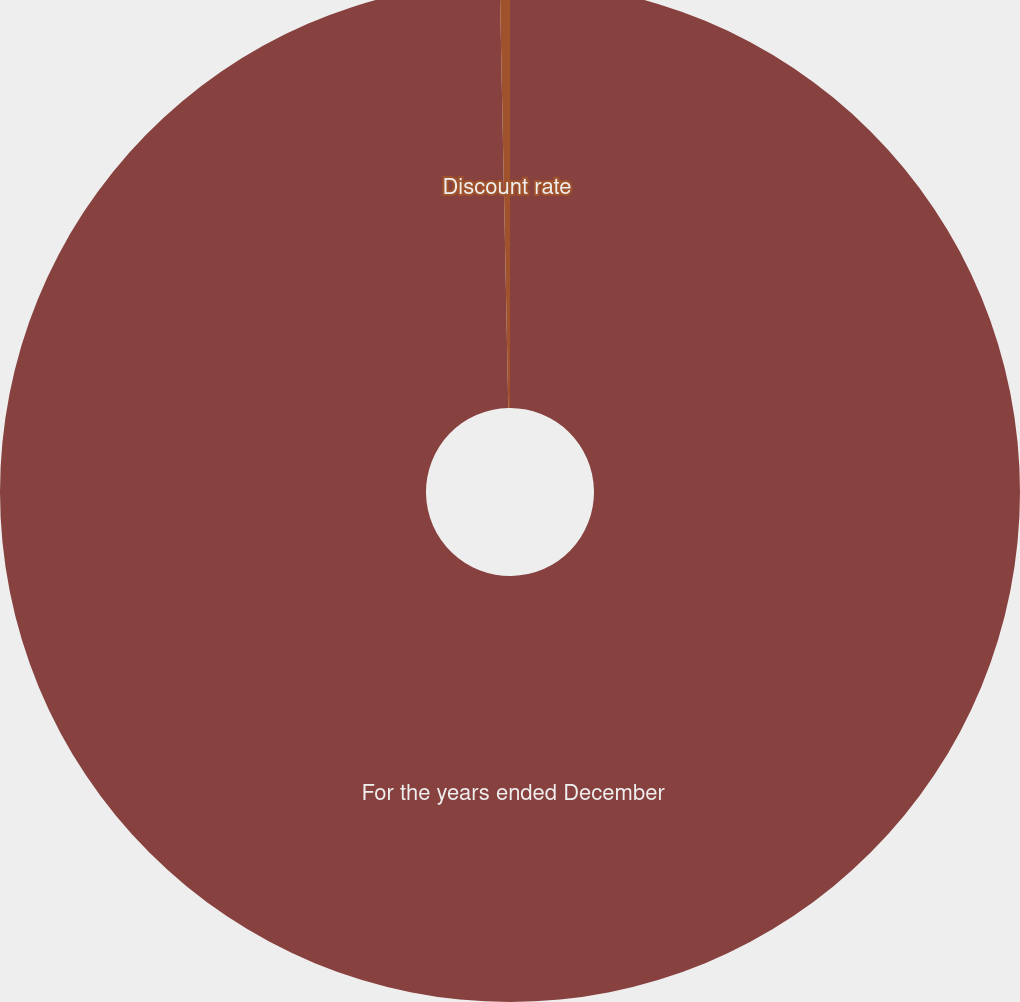Convert chart to OTSL. <chart><loc_0><loc_0><loc_500><loc_500><pie_chart><fcel>For the years ended December<fcel>Discount rate<nl><fcel>99.68%<fcel>0.32%<nl></chart> 